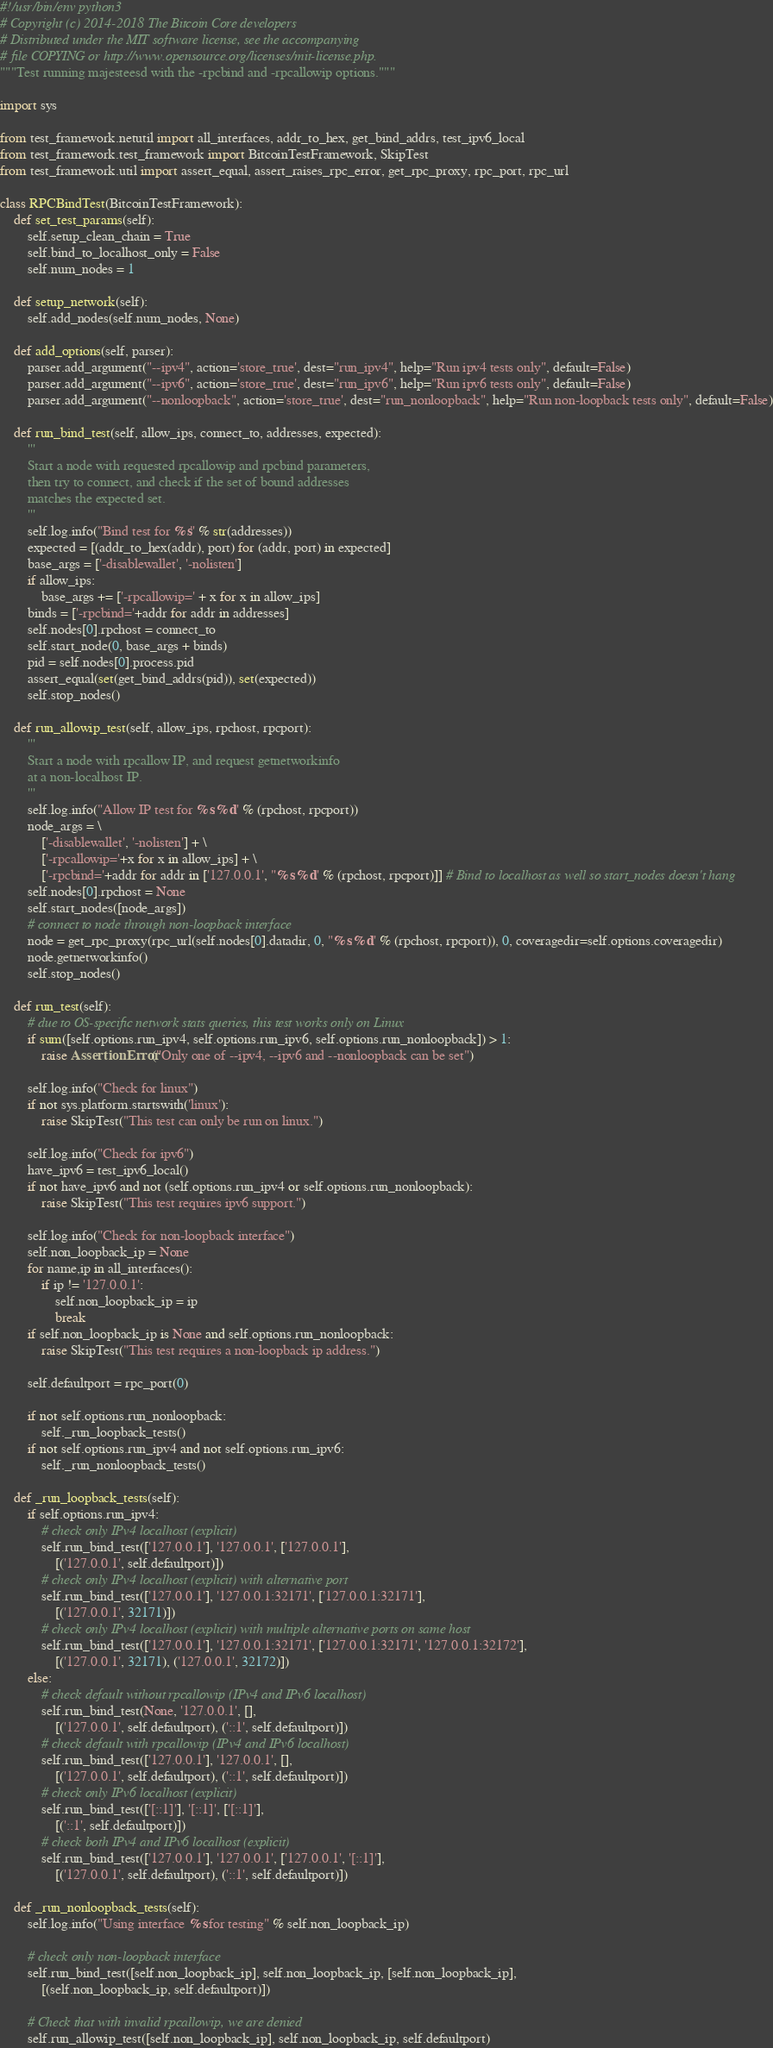<code> <loc_0><loc_0><loc_500><loc_500><_Python_>#!/usr/bin/env python3
# Copyright (c) 2014-2018 The Bitcoin Core developers
# Distributed under the MIT software license, see the accompanying
# file COPYING or http://www.opensource.org/licenses/mit-license.php.
"""Test running majesteesd with the -rpcbind and -rpcallowip options."""

import sys

from test_framework.netutil import all_interfaces, addr_to_hex, get_bind_addrs, test_ipv6_local
from test_framework.test_framework import BitcoinTestFramework, SkipTest
from test_framework.util import assert_equal, assert_raises_rpc_error, get_rpc_proxy, rpc_port, rpc_url

class RPCBindTest(BitcoinTestFramework):
    def set_test_params(self):
        self.setup_clean_chain = True
        self.bind_to_localhost_only = False
        self.num_nodes = 1

    def setup_network(self):
        self.add_nodes(self.num_nodes, None)

    def add_options(self, parser):
        parser.add_argument("--ipv4", action='store_true', dest="run_ipv4", help="Run ipv4 tests only", default=False)
        parser.add_argument("--ipv6", action='store_true', dest="run_ipv6", help="Run ipv6 tests only", default=False)
        parser.add_argument("--nonloopback", action='store_true', dest="run_nonloopback", help="Run non-loopback tests only", default=False)

    def run_bind_test(self, allow_ips, connect_to, addresses, expected):
        '''
        Start a node with requested rpcallowip and rpcbind parameters,
        then try to connect, and check if the set of bound addresses
        matches the expected set.
        '''
        self.log.info("Bind test for %s" % str(addresses))
        expected = [(addr_to_hex(addr), port) for (addr, port) in expected]
        base_args = ['-disablewallet', '-nolisten']
        if allow_ips:
            base_args += ['-rpcallowip=' + x for x in allow_ips]
        binds = ['-rpcbind='+addr for addr in addresses]
        self.nodes[0].rpchost = connect_to
        self.start_node(0, base_args + binds)
        pid = self.nodes[0].process.pid
        assert_equal(set(get_bind_addrs(pid)), set(expected))
        self.stop_nodes()

    def run_allowip_test(self, allow_ips, rpchost, rpcport):
        '''
        Start a node with rpcallow IP, and request getnetworkinfo
        at a non-localhost IP.
        '''
        self.log.info("Allow IP test for %s:%d" % (rpchost, rpcport))
        node_args = \
            ['-disablewallet', '-nolisten'] + \
            ['-rpcallowip='+x for x in allow_ips] + \
            ['-rpcbind='+addr for addr in ['127.0.0.1', "%s:%d" % (rpchost, rpcport)]] # Bind to localhost as well so start_nodes doesn't hang
        self.nodes[0].rpchost = None
        self.start_nodes([node_args])
        # connect to node through non-loopback interface
        node = get_rpc_proxy(rpc_url(self.nodes[0].datadir, 0, "%s:%d" % (rpchost, rpcport)), 0, coveragedir=self.options.coveragedir)
        node.getnetworkinfo()
        self.stop_nodes()

    def run_test(self):
        # due to OS-specific network stats queries, this test works only on Linux
        if sum([self.options.run_ipv4, self.options.run_ipv6, self.options.run_nonloopback]) > 1:
            raise AssertionError("Only one of --ipv4, --ipv6 and --nonloopback can be set")

        self.log.info("Check for linux")
        if not sys.platform.startswith('linux'):
            raise SkipTest("This test can only be run on linux.")

        self.log.info("Check for ipv6")
        have_ipv6 = test_ipv6_local()
        if not have_ipv6 and not (self.options.run_ipv4 or self.options.run_nonloopback):
            raise SkipTest("This test requires ipv6 support.")

        self.log.info("Check for non-loopback interface")
        self.non_loopback_ip = None
        for name,ip in all_interfaces():
            if ip != '127.0.0.1':
                self.non_loopback_ip = ip
                break
        if self.non_loopback_ip is None and self.options.run_nonloopback:
            raise SkipTest("This test requires a non-loopback ip address.")

        self.defaultport = rpc_port(0)

        if not self.options.run_nonloopback:
            self._run_loopback_tests()
        if not self.options.run_ipv4 and not self.options.run_ipv6:
            self._run_nonloopback_tests()

    def _run_loopback_tests(self):
        if self.options.run_ipv4:
            # check only IPv4 localhost (explicit)
            self.run_bind_test(['127.0.0.1'], '127.0.0.1', ['127.0.0.1'],
                [('127.0.0.1', self.defaultport)])
            # check only IPv4 localhost (explicit) with alternative port
            self.run_bind_test(['127.0.0.1'], '127.0.0.1:32171', ['127.0.0.1:32171'],
                [('127.0.0.1', 32171)])
            # check only IPv4 localhost (explicit) with multiple alternative ports on same host
            self.run_bind_test(['127.0.0.1'], '127.0.0.1:32171', ['127.0.0.1:32171', '127.0.0.1:32172'],
                [('127.0.0.1', 32171), ('127.0.0.1', 32172)])
        else:
            # check default without rpcallowip (IPv4 and IPv6 localhost)
            self.run_bind_test(None, '127.0.0.1', [],
                [('127.0.0.1', self.defaultport), ('::1', self.defaultport)])
            # check default with rpcallowip (IPv4 and IPv6 localhost)
            self.run_bind_test(['127.0.0.1'], '127.0.0.1', [],
                [('127.0.0.1', self.defaultport), ('::1', self.defaultport)])
            # check only IPv6 localhost (explicit)
            self.run_bind_test(['[::1]'], '[::1]', ['[::1]'],
                [('::1', self.defaultport)])
            # check both IPv4 and IPv6 localhost (explicit)
            self.run_bind_test(['127.0.0.1'], '127.0.0.1', ['127.0.0.1', '[::1]'],
                [('127.0.0.1', self.defaultport), ('::1', self.defaultport)])

    def _run_nonloopback_tests(self):
        self.log.info("Using interface %s for testing" % self.non_loopback_ip)

        # check only non-loopback interface
        self.run_bind_test([self.non_loopback_ip], self.non_loopback_ip, [self.non_loopback_ip],
            [(self.non_loopback_ip, self.defaultport)])

        # Check that with invalid rpcallowip, we are denied
        self.run_allowip_test([self.non_loopback_ip], self.non_loopback_ip, self.defaultport)</code> 